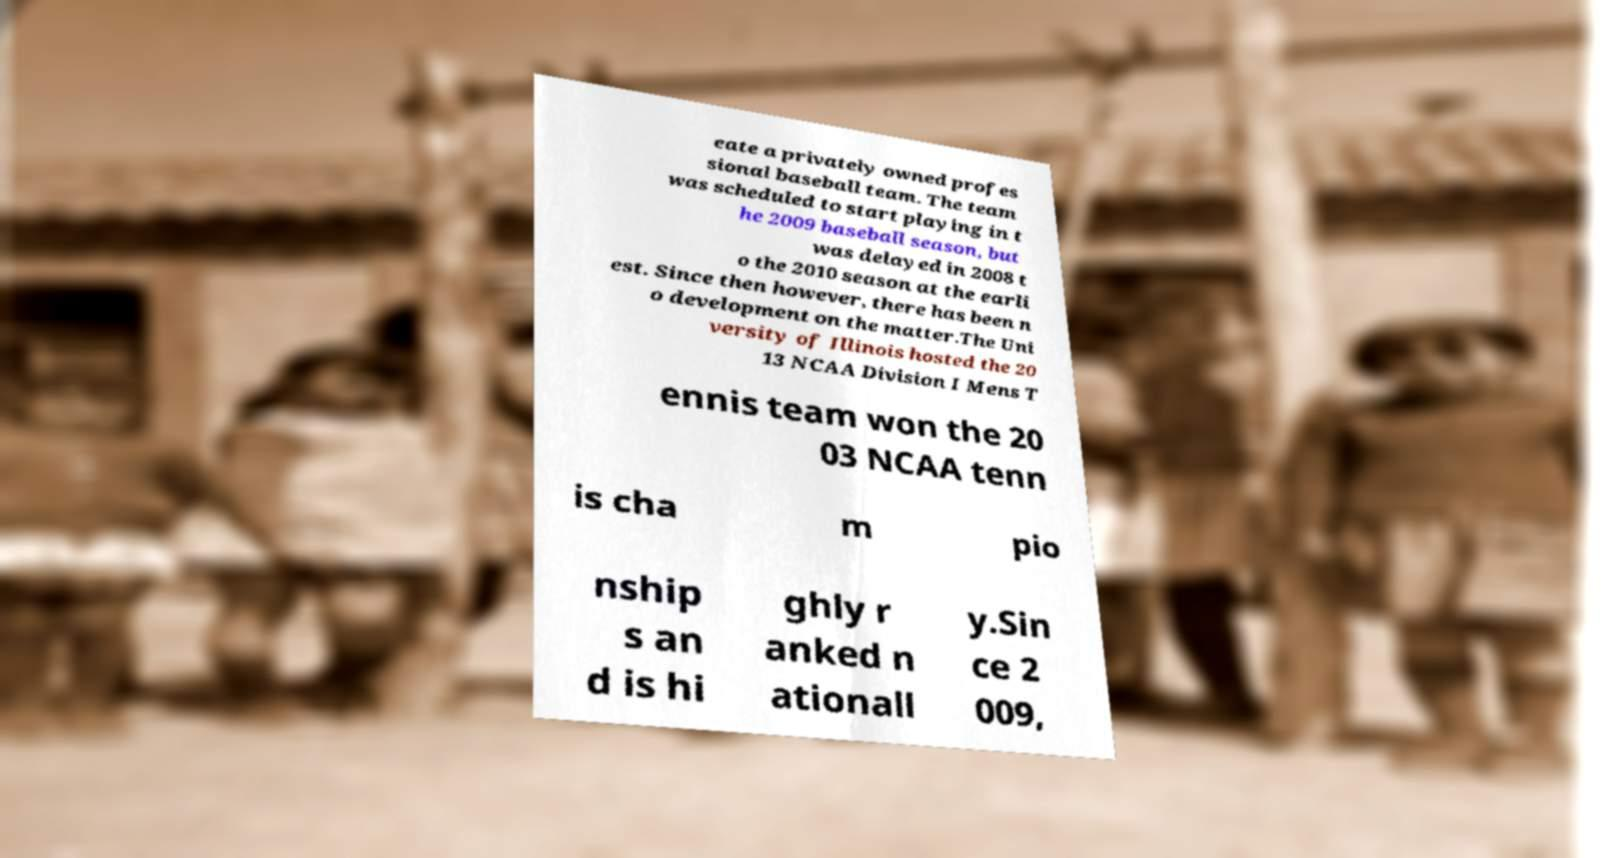Please read and relay the text visible in this image. What does it say? eate a privately owned profes sional baseball team. The team was scheduled to start playing in t he 2009 baseball season, but was delayed in 2008 t o the 2010 season at the earli est. Since then however, there has been n o development on the matter.The Uni versity of Illinois hosted the 20 13 NCAA Division I Mens T ennis team won the 20 03 NCAA tenn is cha m pio nship s an d is hi ghly r anked n ationall y.Sin ce 2 009, 